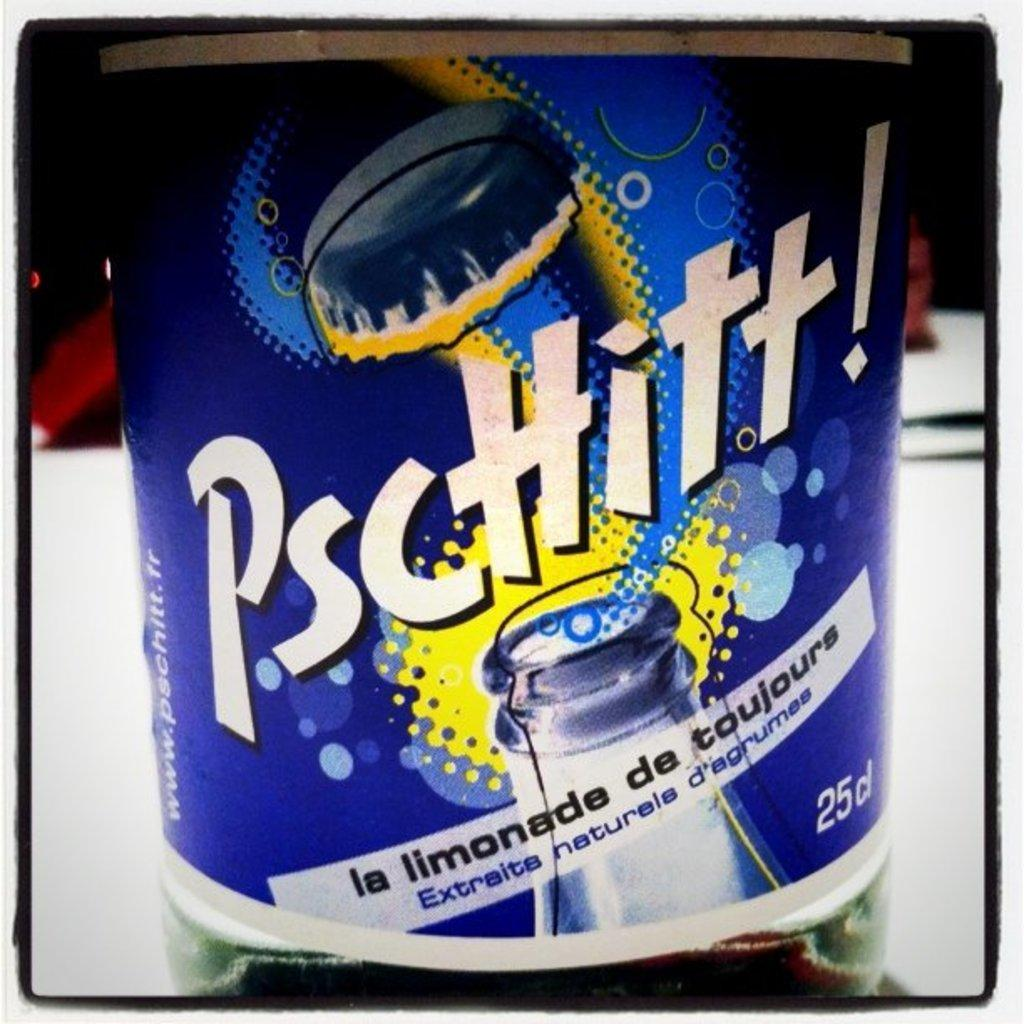<image>
Create a compact narrative representing the image presented. A blue bottle of lemonade is pictured on a white surface. 